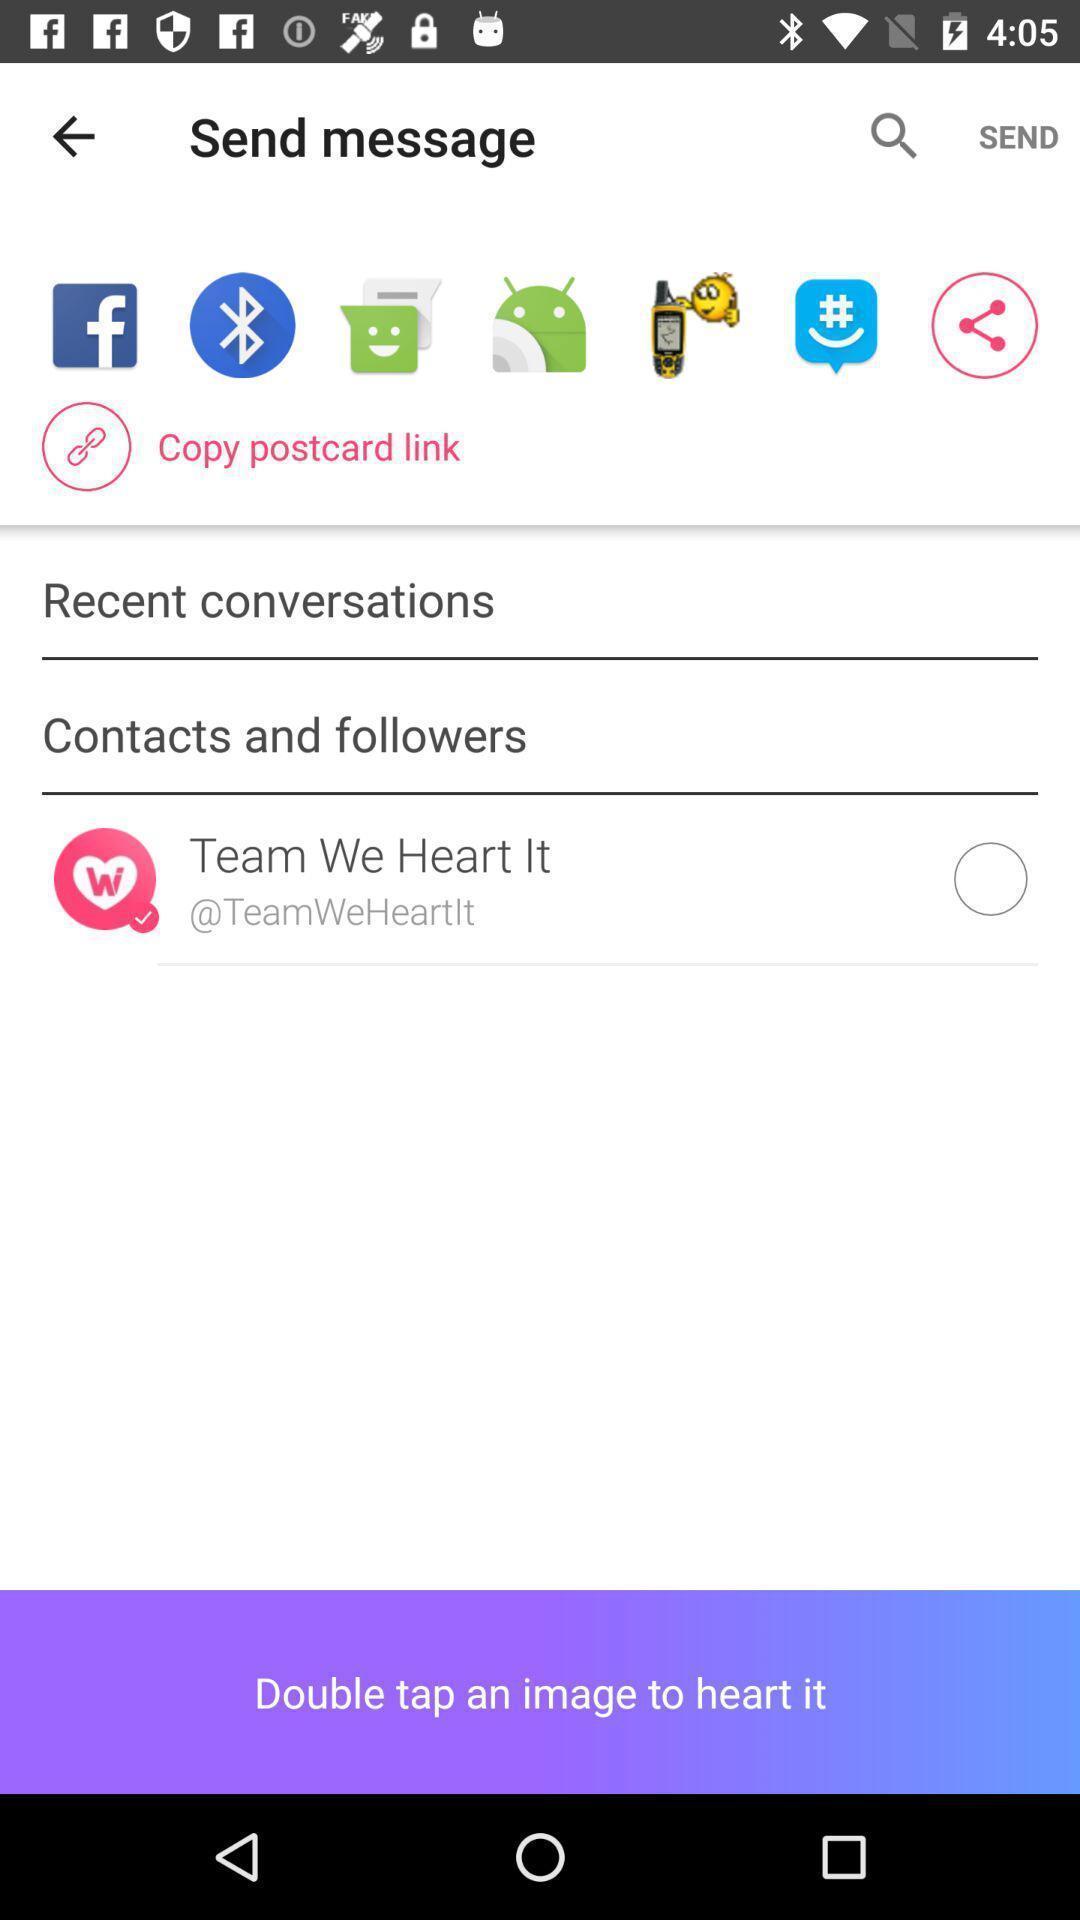Tell me what you see in this picture. Page displays various apps to send message. 